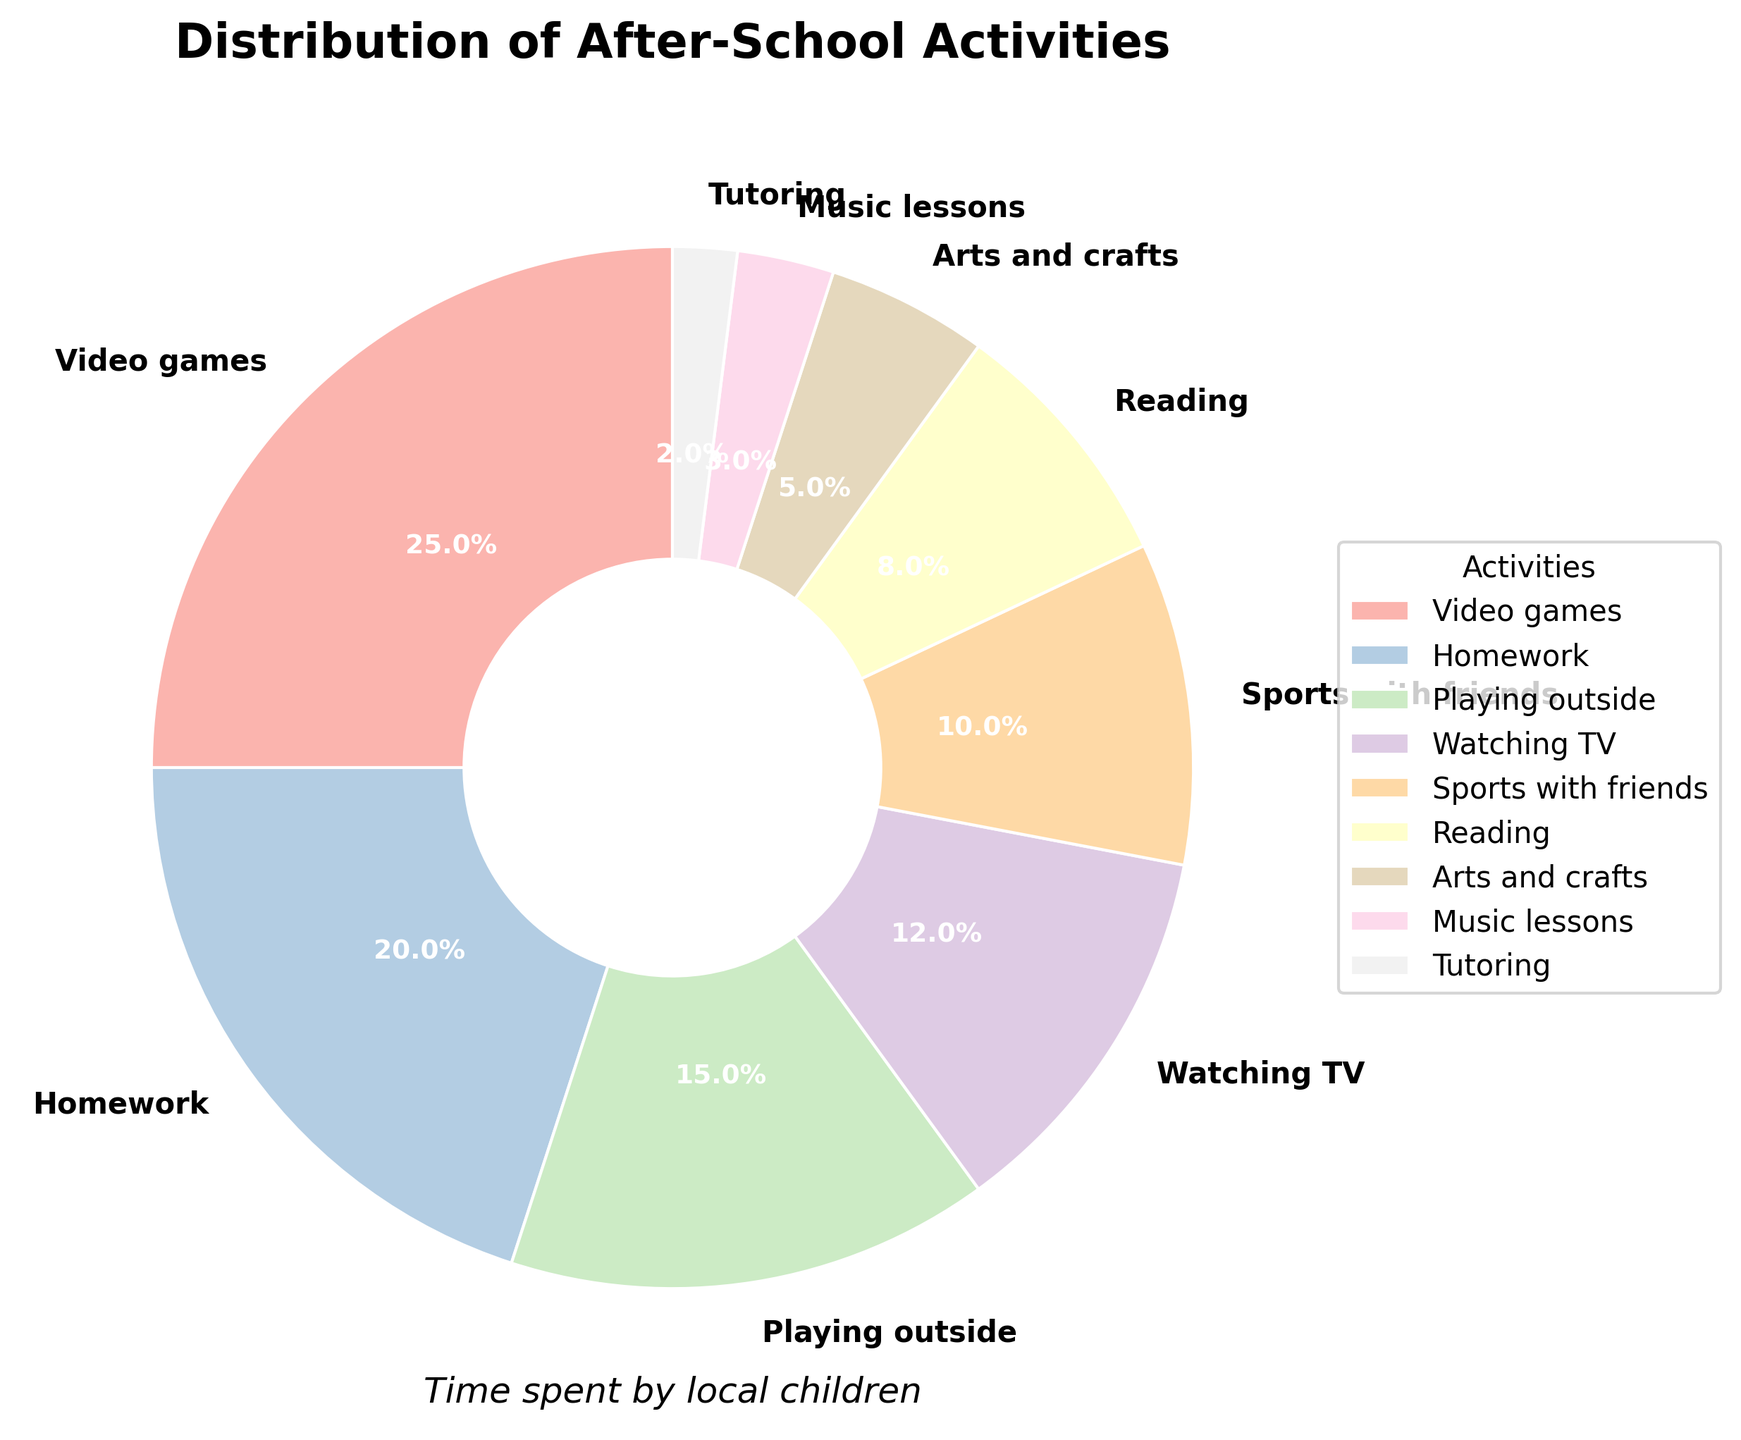Which activity do local children spend the most time on after school? The activity with the largest percentage slice on the pie chart represents the activity that local children spend the most time on. In this case, it is the section labeled "Video games"
Answer: Video games How much more time do children spend on video games compared to reading? The pie chart shows that children spend 25% of their time on video games and 8% on reading. To find the difference, subtract 8% from 25%
Answer: 17% Which activities do children spend more than 10% of their time on? By looking at the pie chart, any section that represents more than 10% time allocation can be determined. These are "Video games" (25%), "Homework" (20%), "Playing outside" (15%), and "Watching TV" (12%)
Answer: Video games, Homework, Playing outside, Watching TV What percentage of time is spent on arts and crafts and music lessons combined? Identify the sections for "Arts and crafts" and "Music lessons" in the pie chart and add their percentages. "Arts and crafts" is 5% and "Music lessons" is 3%. Adding them together gives 5% + 3%
Answer: 8% Is the percentage of time spent on sports with friends greater than the time spent on watching TV? By comparing the slices for "Sports with friends" (10%) and "Watching TV" (12%) on the pie chart, it is clear that 12% is greater than 10%
Answer: No Which activities fall below the 5% mark in terms of time spent? Find the sections in the pie chart that represent less than 5%, which are "Music lessons" (3%) and "Tutoring" (2%)
Answer: Music lessons, Tutoring Are children spending more time on homework or playing outside? By comparing the pie chart sections, "Homework" accounts for 20% and "Playing outside" accounts for 15%. Since 20% is greater than 15%
Answer: Homework What is the total time spent on sports with friends, reading, and tutoring combined? Identify and add the percentages for "Sports with friends" (10%), "Reading" (8%), and "Tutoring" (2%) from the pie chart. The sum is 10% + 8% + 2%
Answer: 20% How does the time spent on arts and crafts compare to the time spent on tutoring? Compare the pie chart sections for "Arts and crafts" (5%) and "Tutoring" (2%). Since 5% is greater than 2%
Answer: More time on arts and crafts What percentage of their after-school time do children spend on non-screen activities (homework, playing outside, sports with friends, reading, arts and crafts, music lessons, tutoring)? Identify the non-screen activities and sum their percentages from the pie chart: Homework (20%), playing outside (15%), sports with friends (10%), reading (8%), arts and crafts (5%), music lessons (3%), tutoring (2%). The total is 20% + 15% + 10% + 8% + 5% + 3% + 2%
Answer: 63% 